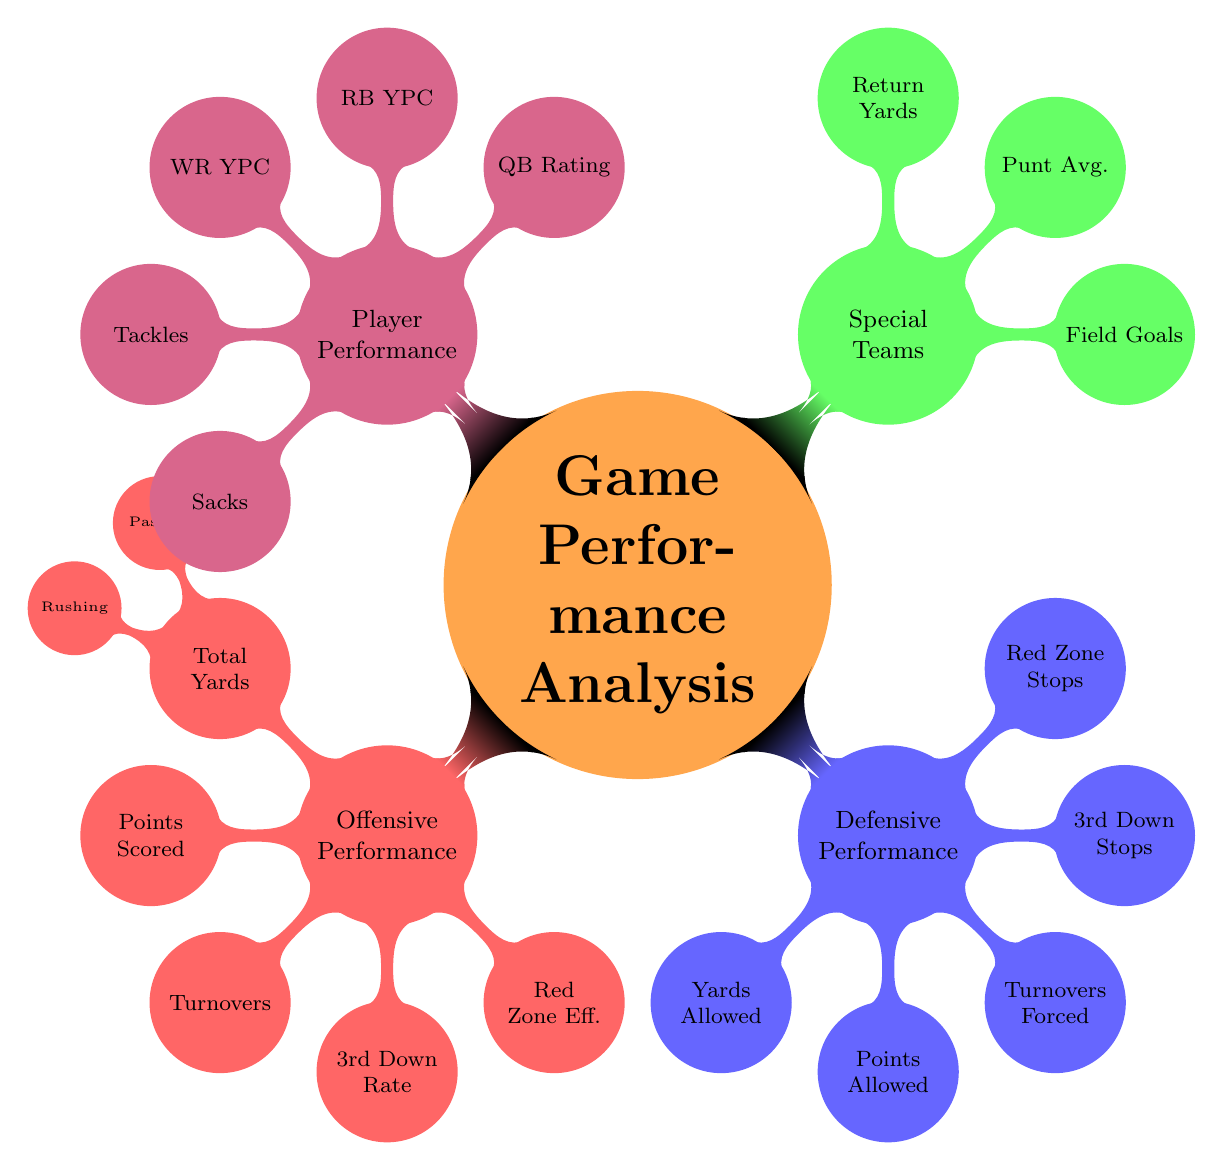What are the two main categories of performance metrics depicted in the diagram? The diagram has two main categories under game performance analysis, which are "Offensive Performance" and "Defensive Performance".
Answer: Offensive Performance, Defensive Performance Which category includes the metric for "Field Goals Made"? "Field Goals Made" is included in the "Special Teams Performance" category of the diagram.
Answer: Special Teams Performance How many performance metrics are listed under "Player Performance"? The "Player Performance" category lists five metrics: "QB Rating", "RB YPC", "WR YPC", "Tackles", and "Sacks", totaling five metrics.
Answer: 5 What are the two types of turnovers addressed in "Offensive Performance"? The "Offensive Performance" category addresses two types of turnovers: "Interceptions" and "Fumbles Lost".
Answer: Interceptions, Fumbles Lost Which performance category has metrics specifically for "Yards Allowed"? "Yards Allowed" is a metric found under the "Defensive Performance" category.
Answer: Defensive Performance Within "Offensive Performance", what two metrics fall under "Total Yards Gained"? The "Total Yards Gained" metric in "Offensive Performance" includes "Passing Yards" and "Rushing Yards".
Answer: Passing Yards, Rushing Yards Which category reports on "Third Down Conversion Rate"? The "Third Down Conversion Rate" metric is reported under "Offensive Performance".
Answer: Offensive Performance How many child nodes does the "Defensive Performance" category have? The "Defensive Performance" category has five child nodes: "Yards Allowed", "Points Allowed", "Turnovers Forced", "3rd Down Stops", and "Red Zone Stops", totaling five child nodes.
Answer: 5 What two metrics are included under "Turnovers Forced"? Under "Turnovers Forced", the two metrics included are "Interceptions" and "Fumble Recoveries".
Answer: Interceptions, Fumble Recoveries 